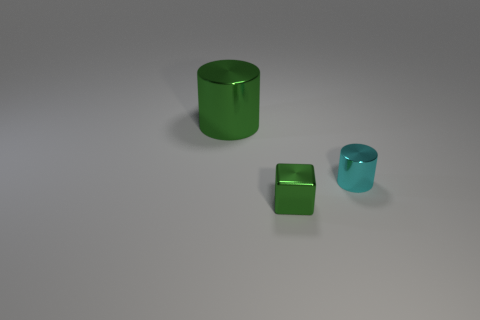There is a cylinder that is on the left side of the tiny green shiny thing; is its size the same as the cylinder on the right side of the big metallic cylinder?
Keep it short and to the point. No. Is there a large shiny thing that has the same shape as the small cyan object?
Offer a very short reply. Yes. Are there the same number of tiny shiny things in front of the cyan object and brown objects?
Provide a succinct answer. No. Is the size of the cyan thing the same as the green cube in front of the big green thing?
Offer a very short reply. Yes. What number of large green things have the same material as the tiny green thing?
Offer a very short reply. 1. Do the cyan thing and the green metallic cylinder have the same size?
Ensure brevity in your answer.  No. Are there any other things of the same color as the tiny metallic cube?
Your answer should be compact. Yes. What shape is the object that is both right of the large green metallic object and on the left side of the cyan metal cylinder?
Your answer should be compact. Cube. How big is the cylinder that is behind the small cyan shiny cylinder?
Your answer should be compact. Large. There is a small metal object left of the small thing right of the tiny green cube; what number of green shiny blocks are behind it?
Keep it short and to the point. 0. 